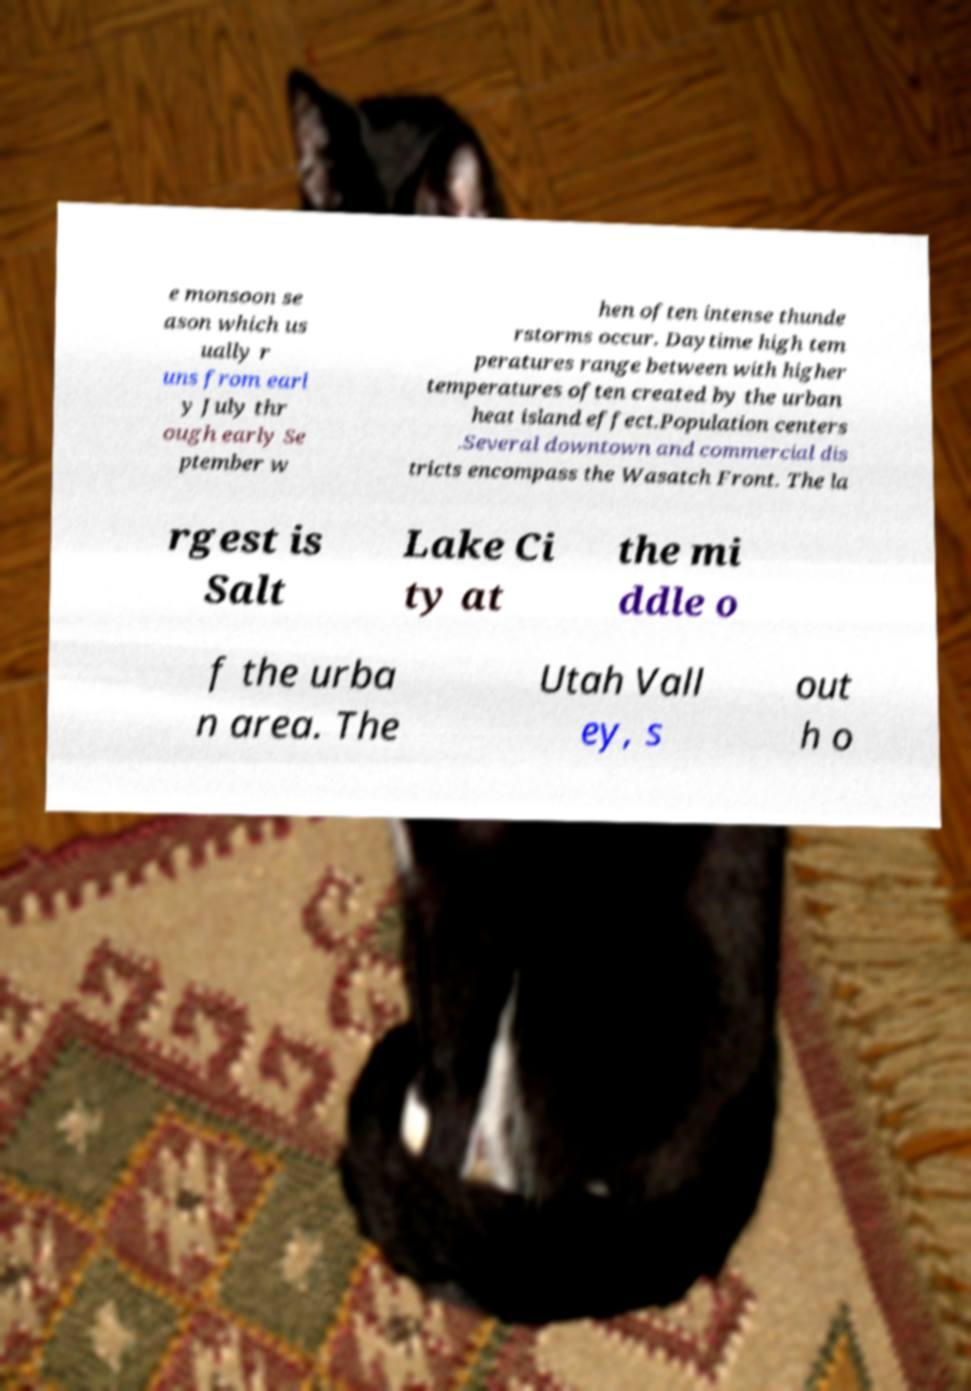Could you assist in decoding the text presented in this image and type it out clearly? e monsoon se ason which us ually r uns from earl y July thr ough early Se ptember w hen often intense thunde rstorms occur. Daytime high tem peratures range between with higher temperatures often created by the urban heat island effect.Population centers .Several downtown and commercial dis tricts encompass the Wasatch Front. The la rgest is Salt Lake Ci ty at the mi ddle o f the urba n area. The Utah Vall ey, s out h o 